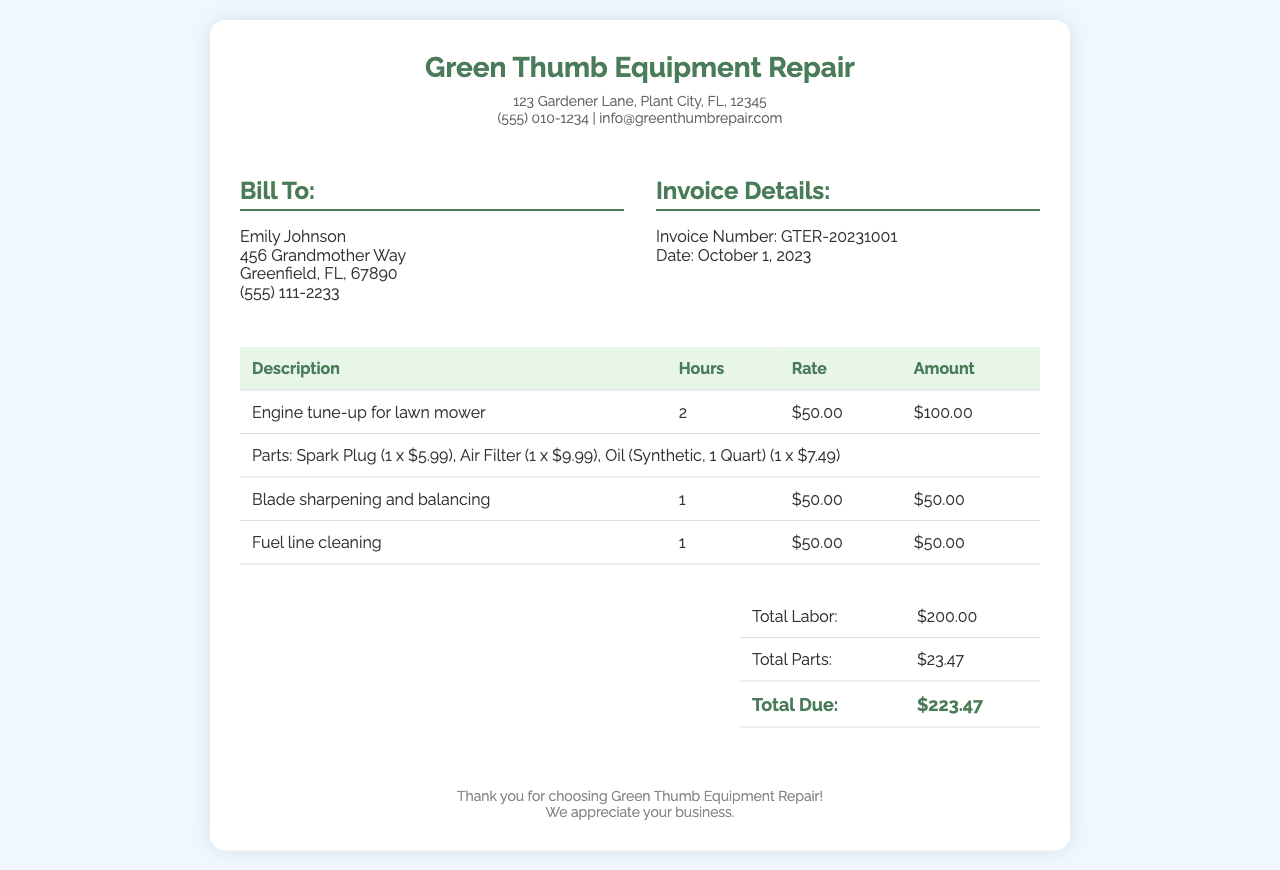What is the business name? The business name is prominently displayed at the top of the invoice, indicating who issued it.
Answer: Green Thumb Equipment Repair What is the invoice number? The invoice number is provided in the invoice details section and is a unique identifier for the transaction.
Answer: GTER-20231001 What date was the invoice issued? The date is also listed in the invoice details section, indicating when the billing occurred.
Answer: October 1, 2023 How many hours were spent on the engine tune-up? The hours for each service are listed in the labor section of the invoice detailing each task performed.
Answer: 2 What is the total labor cost? The total labor cost is calculated from the hours and rate for services performed and is presented in the summary section.
Answer: $200.00 What is the total amount due? This is the overall total that is to be paid for the services and parts combined, found in the summary part of the invoice.
Answer: $223.47 How many parts were listed for the lawn mower? The parts are mentioned in a single item line, and counting them provides the necessary information.
Answer: 3 What service was provided for blade maintenance? The invoice specifies a specific service regarding the maintenance of the mower's blade that was performed.
Answer: Blade sharpening and balancing What is the customer's name listed on the invoice? The name of the person who will receive the bill appears in the customer info section of the document.
Answer: Emily Johnson 